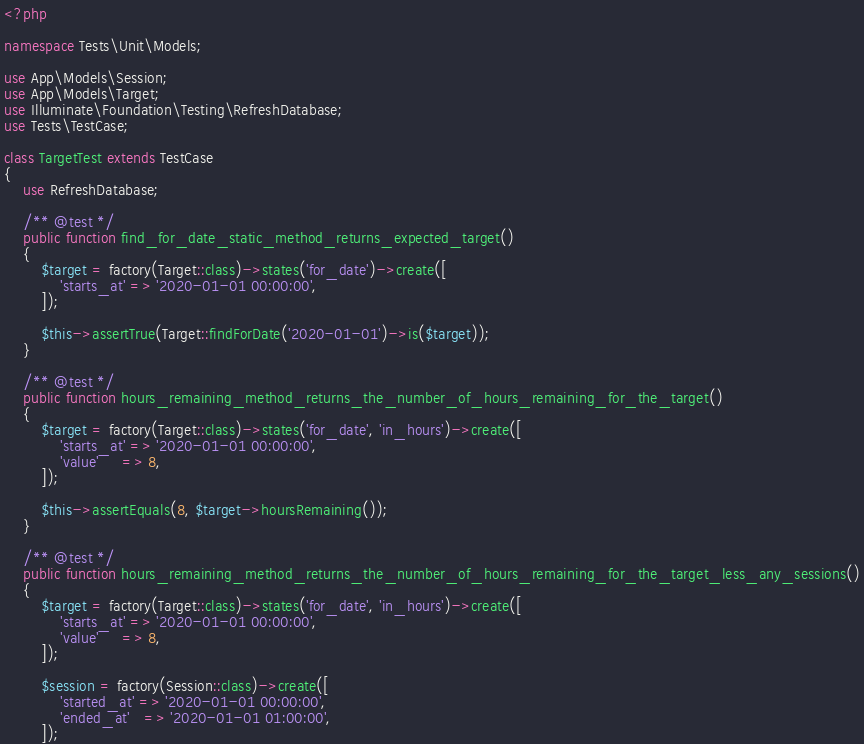<code> <loc_0><loc_0><loc_500><loc_500><_PHP_><?php

namespace Tests\Unit\Models;

use App\Models\Session;
use App\Models\Target;
use Illuminate\Foundation\Testing\RefreshDatabase;
use Tests\TestCase;

class TargetTest extends TestCase
{
    use RefreshDatabase;

    /** @test */
    public function find_for_date_static_method_returns_expected_target()
    {
        $target = factory(Target::class)->states('for_date')->create([
            'starts_at' => '2020-01-01 00:00:00',
        ]);

        $this->assertTrue(Target::findForDate('2020-01-01')->is($target));
    }

    /** @test */
    public function hours_remaining_method_returns_the_number_of_hours_remaining_for_the_target()
    {
        $target = factory(Target::class)->states('for_date', 'in_hours')->create([
            'starts_at' => '2020-01-01 00:00:00',
            'value'     => 8,
        ]);

        $this->assertEquals(8, $target->hoursRemaining());
    }

    /** @test */
    public function hours_remaining_method_returns_the_number_of_hours_remaining_for_the_target_less_any_sessions()
    {
        $target = factory(Target::class)->states('for_date', 'in_hours')->create([
            'starts_at' => '2020-01-01 00:00:00',
            'value'     => 8,
        ]);

        $session = factory(Session::class)->create([
            'started_at' => '2020-01-01 00:00:00',
            'ended_at'   => '2020-01-01 01:00:00',
        ]);
</code> 